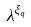<formula> <loc_0><loc_0><loc_500><loc_500>\lambda ^ { \xi _ { q } }</formula> 